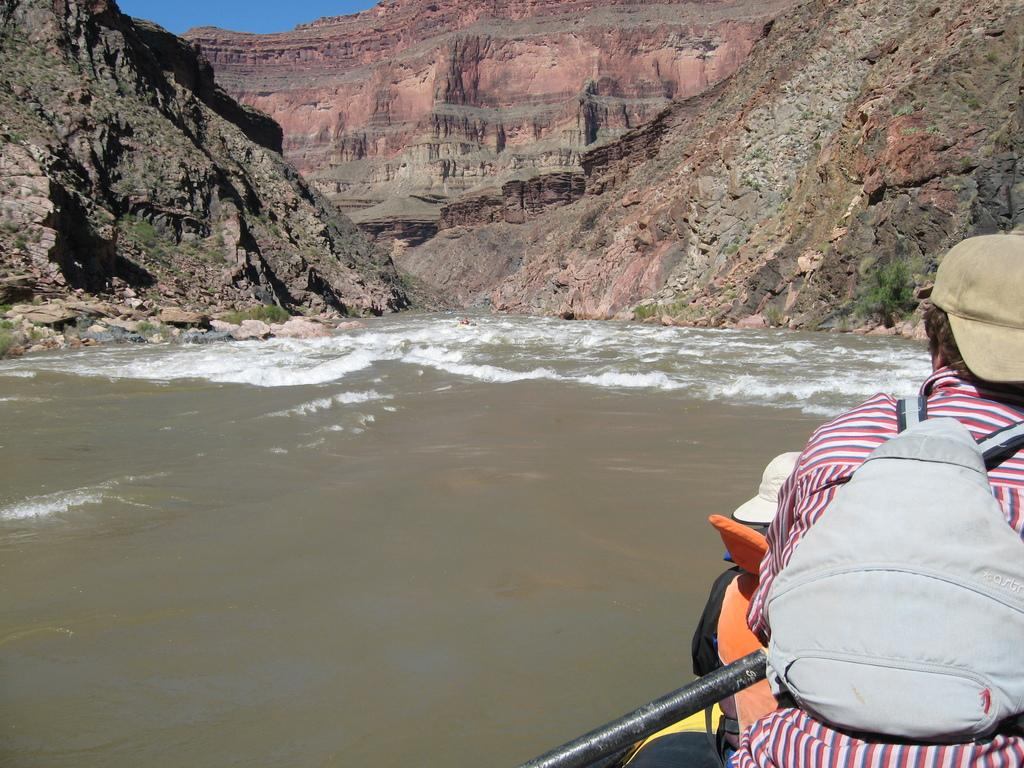What is present in the image that is not solid? There is water in the image. How many people are in the image? There are two persons in the image. What can be seen in the distance in the image? There is a mountain in the background of the image. What else is visible in the background of the image? The sky is visible in the background of the image. What type of farm can be seen in the image? There is no farm present in the image; it features water, two persons, a mountain, and the sky. 